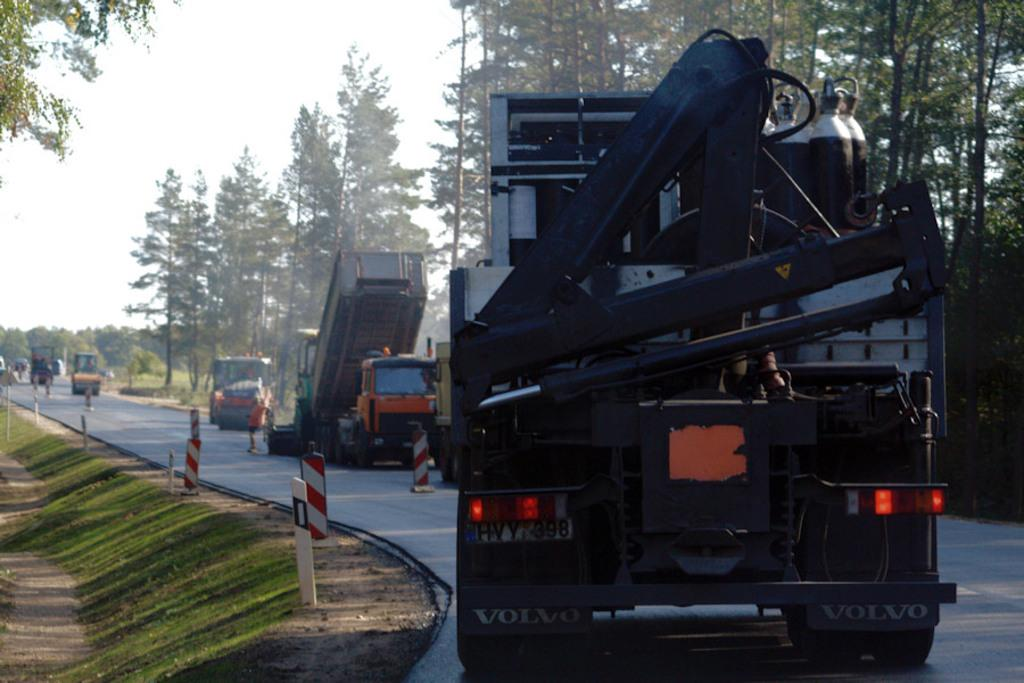What is the main feature of the image? There is a road in the image. What is happening on the road? There are vehicles on the road. Are there any structures along the road? Yes, there are traffic poles in the image. What type of vegetation can be seen in the image? There is grass on the ground and trees in the image. What is the color of the trees? The trees are green in color. What can be seen in the background of the image? The sky is visible in the background of the image. What hobbies are the trees participating in during the protest in the image? There is no protest or hobbies mentioned in the image; it features a road with vehicles, traffic poles, grass, trees, and a visible sky. What type of pump is connected to the trees in the image? There is no pump connected to the trees in the image; it only shows trees with green leaves. 